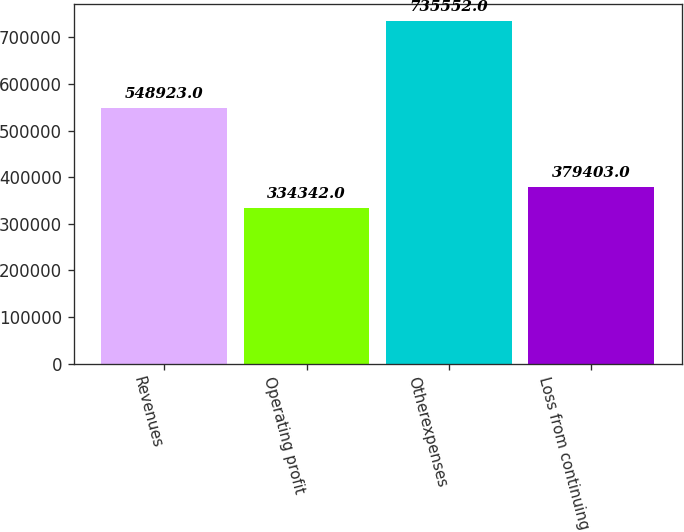Convert chart. <chart><loc_0><loc_0><loc_500><loc_500><bar_chart><fcel>Revenues<fcel>Operating profit<fcel>Otherexpenses<fcel>Loss from continuing<nl><fcel>548923<fcel>334342<fcel>735552<fcel>379403<nl></chart> 